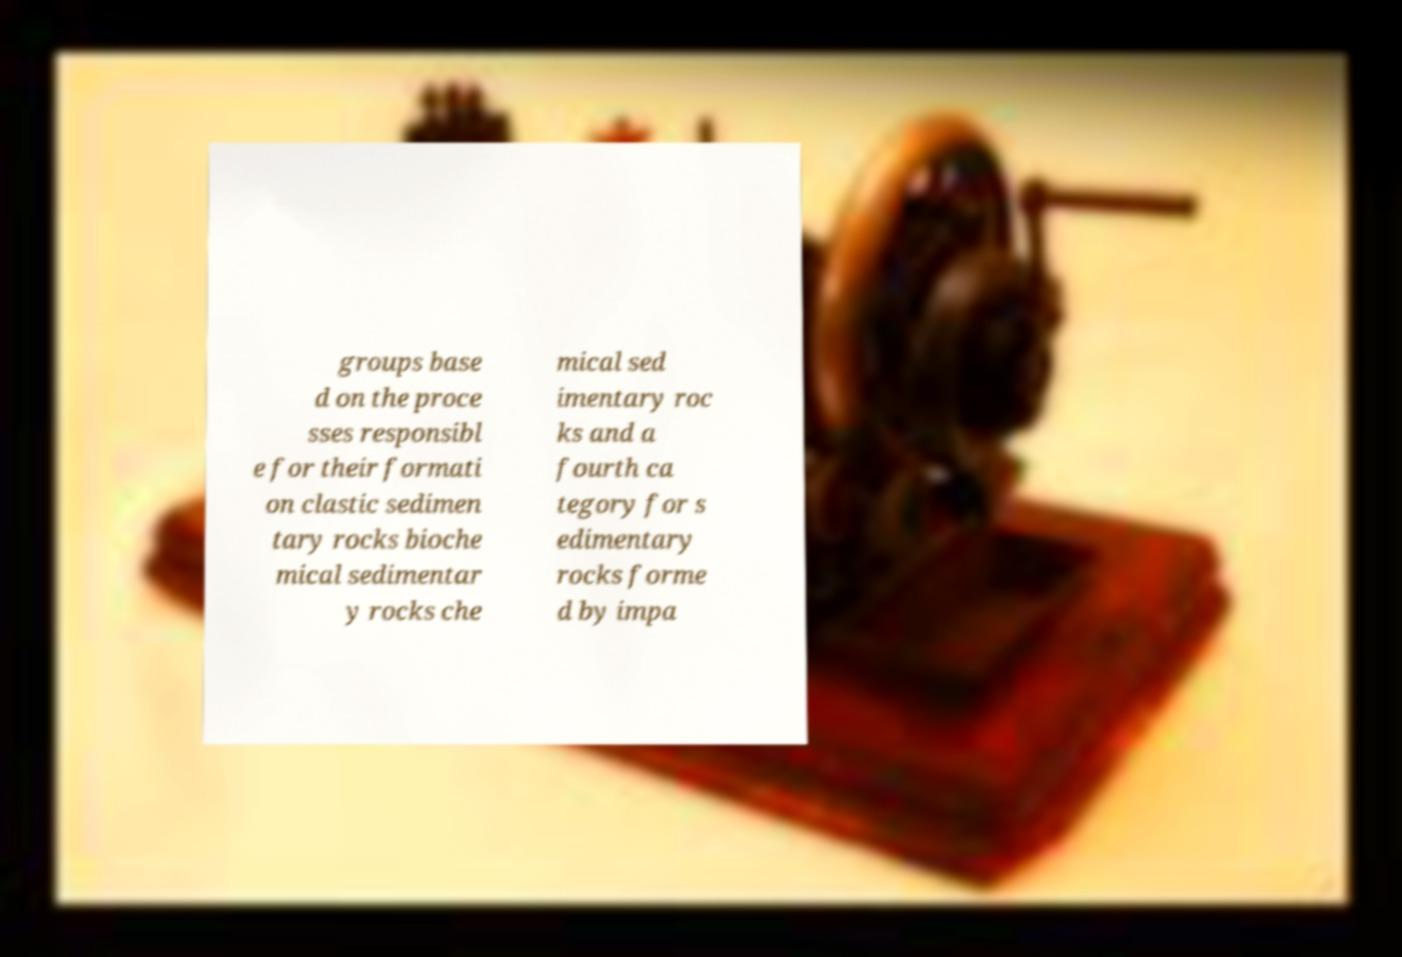Can you accurately transcribe the text from the provided image for me? groups base d on the proce sses responsibl e for their formati on clastic sedimen tary rocks bioche mical sedimentar y rocks che mical sed imentary roc ks and a fourth ca tegory for s edimentary rocks forme d by impa 